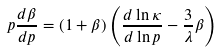<formula> <loc_0><loc_0><loc_500><loc_500>p \frac { d \beta } { d p } = ( 1 + \beta ) \left ( \frac { d \ln \kappa } { d \ln p } - \frac { 3 } { \lambda } \beta \right )</formula> 